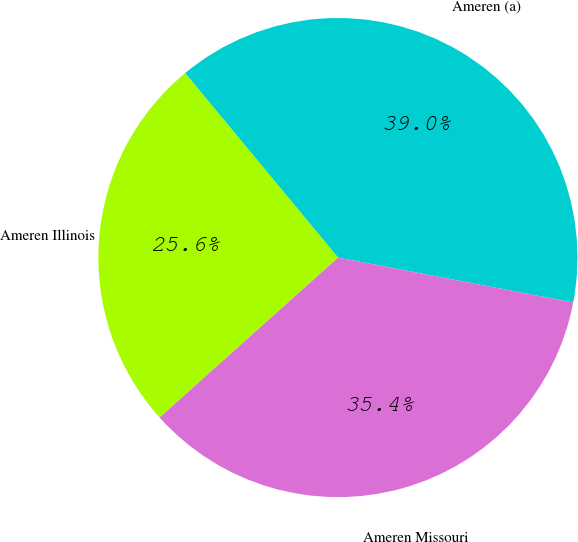Convert chart to OTSL. <chart><loc_0><loc_0><loc_500><loc_500><pie_chart><fcel>Ameren (a)<fcel>Ameren Missouri<fcel>Ameren Illinois<nl><fcel>39.02%<fcel>35.37%<fcel>25.61%<nl></chart> 